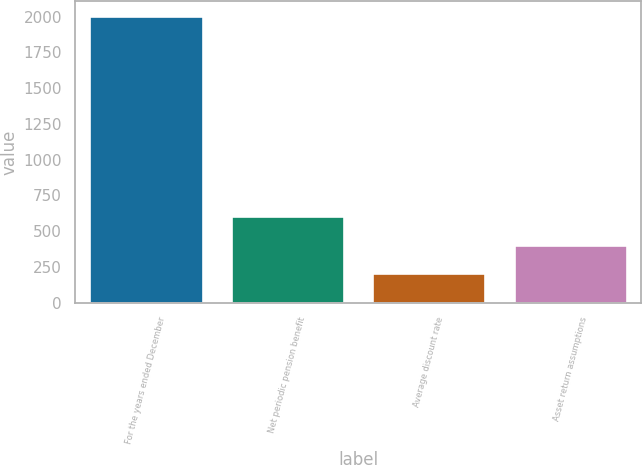Convert chart. <chart><loc_0><loc_0><loc_500><loc_500><bar_chart><fcel>For the years ended December<fcel>Net periodic pension benefit<fcel>Average discount rate<fcel>Asset return assumptions<nl><fcel>2007<fcel>606.16<fcel>205.92<fcel>406.04<nl></chart> 